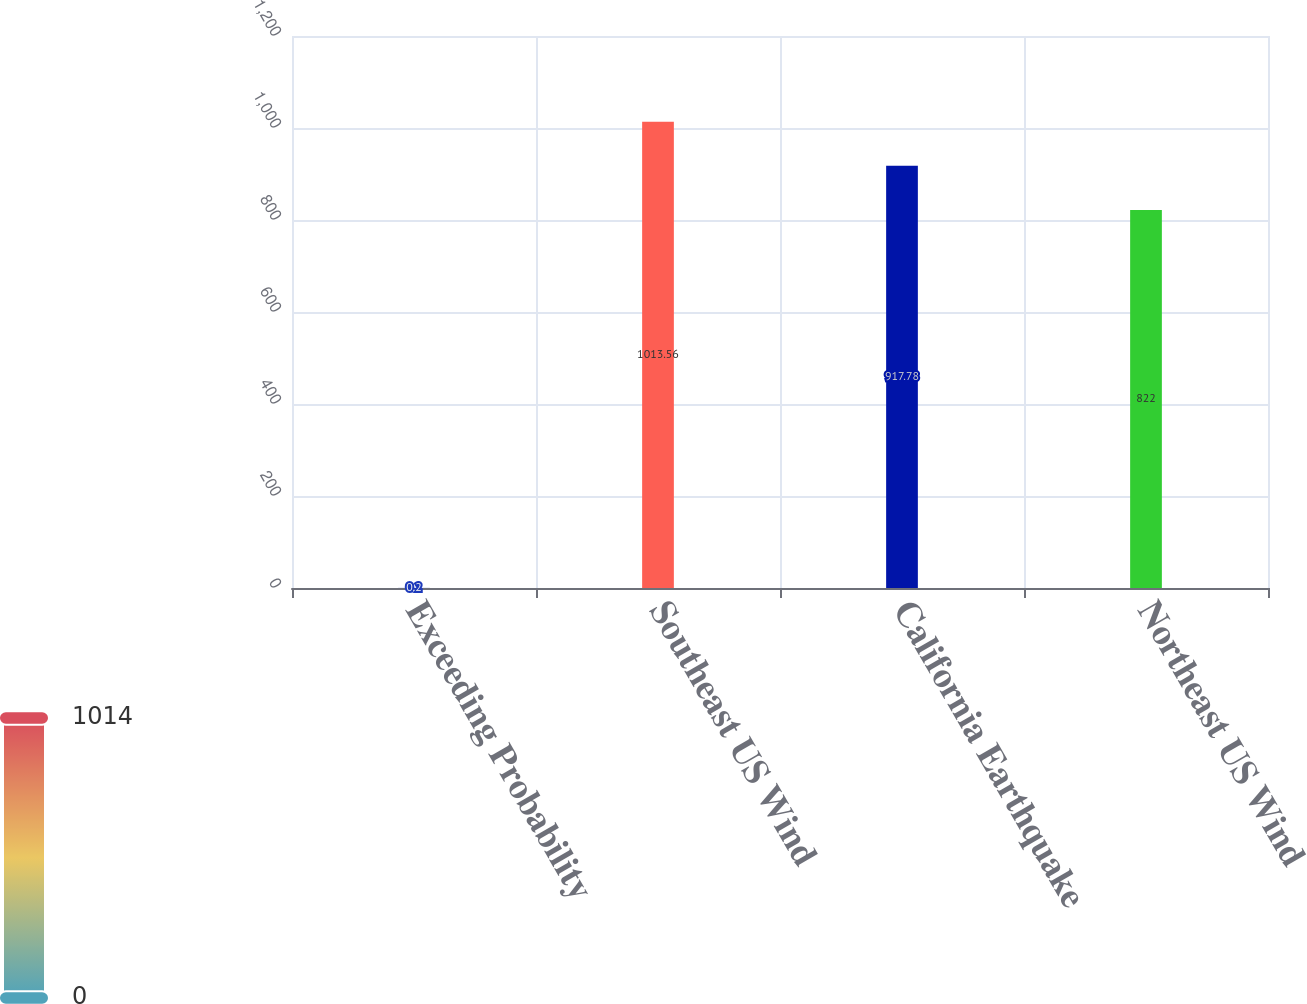Convert chart to OTSL. <chart><loc_0><loc_0><loc_500><loc_500><bar_chart><fcel>Exceeding Probability<fcel>Southeast US Wind<fcel>California Earthquake<fcel>Northeast US Wind<nl><fcel>0.2<fcel>1013.56<fcel>917.78<fcel>822<nl></chart> 